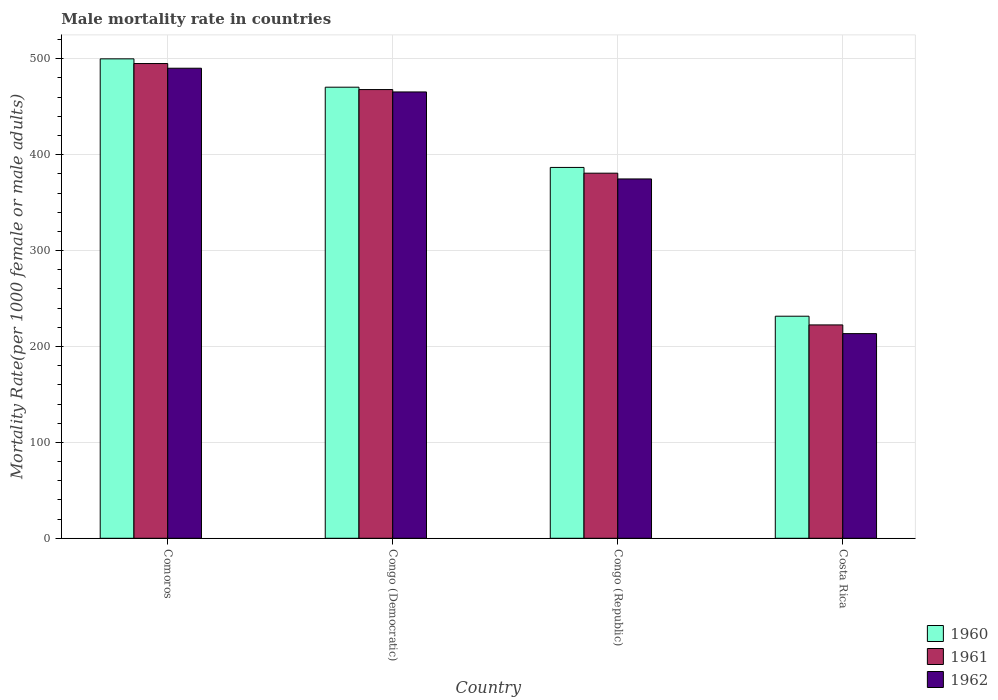Are the number of bars per tick equal to the number of legend labels?
Your answer should be compact. Yes. How many bars are there on the 4th tick from the left?
Provide a short and direct response. 3. How many bars are there on the 4th tick from the right?
Offer a terse response. 3. What is the label of the 2nd group of bars from the left?
Provide a short and direct response. Congo (Democratic). In how many cases, is the number of bars for a given country not equal to the number of legend labels?
Ensure brevity in your answer.  0. What is the male mortality rate in 1960 in Congo (Republic)?
Offer a very short reply. 386.67. Across all countries, what is the maximum male mortality rate in 1962?
Your answer should be compact. 490.1. Across all countries, what is the minimum male mortality rate in 1962?
Keep it short and to the point. 213.38. In which country was the male mortality rate in 1962 maximum?
Provide a short and direct response. Comoros. In which country was the male mortality rate in 1960 minimum?
Offer a terse response. Costa Rica. What is the total male mortality rate in 1961 in the graph?
Your answer should be very brief. 1565.96. What is the difference between the male mortality rate in 1960 in Congo (Democratic) and that in Costa Rica?
Ensure brevity in your answer.  238.8. What is the difference between the male mortality rate in 1961 in Congo (Republic) and the male mortality rate in 1960 in Costa Rica?
Provide a short and direct response. 149.13. What is the average male mortality rate in 1962 per country?
Provide a succinct answer. 385.88. What is the difference between the male mortality rate of/in 1961 and male mortality rate of/in 1962 in Comoros?
Offer a very short reply. 4.89. In how many countries, is the male mortality rate in 1960 greater than 300?
Keep it short and to the point. 3. What is the ratio of the male mortality rate in 1962 in Comoros to that in Costa Rica?
Ensure brevity in your answer.  2.3. Is the male mortality rate in 1961 in Congo (Democratic) less than that in Congo (Republic)?
Provide a succinct answer. No. Is the difference between the male mortality rate in 1961 in Comoros and Congo (Democratic) greater than the difference between the male mortality rate in 1962 in Comoros and Congo (Democratic)?
Offer a very short reply. Yes. What is the difference between the highest and the second highest male mortality rate in 1960?
Offer a very short reply. -113.21. What is the difference between the highest and the lowest male mortality rate in 1960?
Offer a terse response. 268.35. What does the 1st bar from the left in Congo (Democratic) represents?
Make the answer very short. 1960. What does the 1st bar from the right in Congo (Democratic) represents?
Your answer should be compact. 1962. How many bars are there?
Keep it short and to the point. 12. Are the values on the major ticks of Y-axis written in scientific E-notation?
Your response must be concise. No. Does the graph contain grids?
Your answer should be compact. Yes. Where does the legend appear in the graph?
Give a very brief answer. Bottom right. How many legend labels are there?
Give a very brief answer. 3. How are the legend labels stacked?
Your response must be concise. Vertical. What is the title of the graph?
Give a very brief answer. Male mortality rate in countries. Does "2002" appear as one of the legend labels in the graph?
Provide a succinct answer. No. What is the label or title of the Y-axis?
Provide a succinct answer. Mortality Rate(per 1000 female or male adults). What is the Mortality Rate(per 1000 female or male adults) in 1960 in Comoros?
Make the answer very short. 499.88. What is the Mortality Rate(per 1000 female or male adults) of 1961 in Comoros?
Make the answer very short. 494.99. What is the Mortality Rate(per 1000 female or male adults) of 1962 in Comoros?
Ensure brevity in your answer.  490.1. What is the Mortality Rate(per 1000 female or male adults) of 1960 in Congo (Democratic)?
Ensure brevity in your answer.  470.33. What is the Mortality Rate(per 1000 female or male adults) of 1961 in Congo (Democratic)?
Offer a very short reply. 467.85. What is the Mortality Rate(per 1000 female or male adults) of 1962 in Congo (Democratic)?
Your response must be concise. 465.37. What is the Mortality Rate(per 1000 female or male adults) in 1960 in Congo (Republic)?
Make the answer very short. 386.67. What is the Mortality Rate(per 1000 female or male adults) in 1961 in Congo (Republic)?
Offer a terse response. 380.66. What is the Mortality Rate(per 1000 female or male adults) in 1962 in Congo (Republic)?
Your answer should be compact. 374.66. What is the Mortality Rate(per 1000 female or male adults) of 1960 in Costa Rica?
Provide a succinct answer. 231.53. What is the Mortality Rate(per 1000 female or male adults) of 1961 in Costa Rica?
Offer a very short reply. 222.46. What is the Mortality Rate(per 1000 female or male adults) of 1962 in Costa Rica?
Offer a very short reply. 213.38. Across all countries, what is the maximum Mortality Rate(per 1000 female or male adults) in 1960?
Provide a short and direct response. 499.88. Across all countries, what is the maximum Mortality Rate(per 1000 female or male adults) of 1961?
Keep it short and to the point. 494.99. Across all countries, what is the maximum Mortality Rate(per 1000 female or male adults) in 1962?
Give a very brief answer. 490.1. Across all countries, what is the minimum Mortality Rate(per 1000 female or male adults) in 1960?
Your answer should be very brief. 231.53. Across all countries, what is the minimum Mortality Rate(per 1000 female or male adults) in 1961?
Make the answer very short. 222.46. Across all countries, what is the minimum Mortality Rate(per 1000 female or male adults) in 1962?
Your answer should be very brief. 213.38. What is the total Mortality Rate(per 1000 female or male adults) in 1960 in the graph?
Your response must be concise. 1588.41. What is the total Mortality Rate(per 1000 female or male adults) in 1961 in the graph?
Give a very brief answer. 1565.96. What is the total Mortality Rate(per 1000 female or male adults) of 1962 in the graph?
Make the answer very short. 1543.52. What is the difference between the Mortality Rate(per 1000 female or male adults) in 1960 in Comoros and that in Congo (Democratic)?
Ensure brevity in your answer.  29.55. What is the difference between the Mortality Rate(per 1000 female or male adults) in 1961 in Comoros and that in Congo (Democratic)?
Provide a succinct answer. 27.14. What is the difference between the Mortality Rate(per 1000 female or male adults) of 1962 in Comoros and that in Congo (Democratic)?
Offer a terse response. 24.73. What is the difference between the Mortality Rate(per 1000 female or male adults) in 1960 in Comoros and that in Congo (Republic)?
Your response must be concise. 113.21. What is the difference between the Mortality Rate(per 1000 female or male adults) of 1961 in Comoros and that in Congo (Republic)?
Your answer should be compact. 114.33. What is the difference between the Mortality Rate(per 1000 female or male adults) of 1962 in Comoros and that in Congo (Republic)?
Give a very brief answer. 115.44. What is the difference between the Mortality Rate(per 1000 female or male adults) in 1960 in Comoros and that in Costa Rica?
Ensure brevity in your answer.  268.35. What is the difference between the Mortality Rate(per 1000 female or male adults) of 1961 in Comoros and that in Costa Rica?
Your response must be concise. 272.53. What is the difference between the Mortality Rate(per 1000 female or male adults) of 1962 in Comoros and that in Costa Rica?
Give a very brief answer. 276.71. What is the difference between the Mortality Rate(per 1000 female or male adults) of 1960 in Congo (Democratic) and that in Congo (Republic)?
Offer a terse response. 83.66. What is the difference between the Mortality Rate(per 1000 female or male adults) in 1961 in Congo (Democratic) and that in Congo (Republic)?
Provide a succinct answer. 87.19. What is the difference between the Mortality Rate(per 1000 female or male adults) in 1962 in Congo (Democratic) and that in Congo (Republic)?
Offer a terse response. 90.71. What is the difference between the Mortality Rate(per 1000 female or male adults) in 1960 in Congo (Democratic) and that in Costa Rica?
Your answer should be compact. 238.8. What is the difference between the Mortality Rate(per 1000 female or male adults) in 1961 in Congo (Democratic) and that in Costa Rica?
Ensure brevity in your answer.  245.39. What is the difference between the Mortality Rate(per 1000 female or male adults) of 1962 in Congo (Democratic) and that in Costa Rica?
Make the answer very short. 251.99. What is the difference between the Mortality Rate(per 1000 female or male adults) of 1960 in Congo (Republic) and that in Costa Rica?
Your answer should be compact. 155.14. What is the difference between the Mortality Rate(per 1000 female or male adults) of 1961 in Congo (Republic) and that in Costa Rica?
Keep it short and to the point. 158.21. What is the difference between the Mortality Rate(per 1000 female or male adults) in 1962 in Congo (Republic) and that in Costa Rica?
Make the answer very short. 161.28. What is the difference between the Mortality Rate(per 1000 female or male adults) of 1960 in Comoros and the Mortality Rate(per 1000 female or male adults) of 1961 in Congo (Democratic)?
Ensure brevity in your answer.  32.03. What is the difference between the Mortality Rate(per 1000 female or male adults) of 1960 in Comoros and the Mortality Rate(per 1000 female or male adults) of 1962 in Congo (Democratic)?
Your answer should be very brief. 34.51. What is the difference between the Mortality Rate(per 1000 female or male adults) in 1961 in Comoros and the Mortality Rate(per 1000 female or male adults) in 1962 in Congo (Democratic)?
Ensure brevity in your answer.  29.62. What is the difference between the Mortality Rate(per 1000 female or male adults) of 1960 in Comoros and the Mortality Rate(per 1000 female or male adults) of 1961 in Congo (Republic)?
Ensure brevity in your answer.  119.22. What is the difference between the Mortality Rate(per 1000 female or male adults) of 1960 in Comoros and the Mortality Rate(per 1000 female or male adults) of 1962 in Congo (Republic)?
Keep it short and to the point. 125.22. What is the difference between the Mortality Rate(per 1000 female or male adults) in 1961 in Comoros and the Mortality Rate(per 1000 female or male adults) in 1962 in Congo (Republic)?
Your answer should be compact. 120.33. What is the difference between the Mortality Rate(per 1000 female or male adults) in 1960 in Comoros and the Mortality Rate(per 1000 female or male adults) in 1961 in Costa Rica?
Provide a succinct answer. 277.42. What is the difference between the Mortality Rate(per 1000 female or male adults) in 1960 in Comoros and the Mortality Rate(per 1000 female or male adults) in 1962 in Costa Rica?
Make the answer very short. 286.5. What is the difference between the Mortality Rate(per 1000 female or male adults) of 1961 in Comoros and the Mortality Rate(per 1000 female or male adults) of 1962 in Costa Rica?
Offer a terse response. 281.61. What is the difference between the Mortality Rate(per 1000 female or male adults) in 1960 in Congo (Democratic) and the Mortality Rate(per 1000 female or male adults) in 1961 in Congo (Republic)?
Your answer should be compact. 89.67. What is the difference between the Mortality Rate(per 1000 female or male adults) in 1960 in Congo (Democratic) and the Mortality Rate(per 1000 female or male adults) in 1962 in Congo (Republic)?
Provide a succinct answer. 95.67. What is the difference between the Mortality Rate(per 1000 female or male adults) in 1961 in Congo (Democratic) and the Mortality Rate(per 1000 female or male adults) in 1962 in Congo (Republic)?
Provide a succinct answer. 93.19. What is the difference between the Mortality Rate(per 1000 female or male adults) of 1960 in Congo (Democratic) and the Mortality Rate(per 1000 female or male adults) of 1961 in Costa Rica?
Provide a succinct answer. 247.87. What is the difference between the Mortality Rate(per 1000 female or male adults) in 1960 in Congo (Democratic) and the Mortality Rate(per 1000 female or male adults) in 1962 in Costa Rica?
Provide a succinct answer. 256.94. What is the difference between the Mortality Rate(per 1000 female or male adults) of 1961 in Congo (Democratic) and the Mortality Rate(per 1000 female or male adults) of 1962 in Costa Rica?
Give a very brief answer. 254.47. What is the difference between the Mortality Rate(per 1000 female or male adults) in 1960 in Congo (Republic) and the Mortality Rate(per 1000 female or male adults) in 1961 in Costa Rica?
Offer a terse response. 164.21. What is the difference between the Mortality Rate(per 1000 female or male adults) in 1960 in Congo (Republic) and the Mortality Rate(per 1000 female or male adults) in 1962 in Costa Rica?
Provide a short and direct response. 173.28. What is the difference between the Mortality Rate(per 1000 female or male adults) of 1961 in Congo (Republic) and the Mortality Rate(per 1000 female or male adults) of 1962 in Costa Rica?
Your answer should be very brief. 167.28. What is the average Mortality Rate(per 1000 female or male adults) in 1960 per country?
Your answer should be very brief. 397.1. What is the average Mortality Rate(per 1000 female or male adults) in 1961 per country?
Ensure brevity in your answer.  391.49. What is the average Mortality Rate(per 1000 female or male adults) of 1962 per country?
Keep it short and to the point. 385.88. What is the difference between the Mortality Rate(per 1000 female or male adults) of 1960 and Mortality Rate(per 1000 female or male adults) of 1961 in Comoros?
Provide a succinct answer. 4.89. What is the difference between the Mortality Rate(per 1000 female or male adults) of 1960 and Mortality Rate(per 1000 female or male adults) of 1962 in Comoros?
Offer a terse response. 9.78. What is the difference between the Mortality Rate(per 1000 female or male adults) of 1961 and Mortality Rate(per 1000 female or male adults) of 1962 in Comoros?
Offer a very short reply. 4.89. What is the difference between the Mortality Rate(per 1000 female or male adults) in 1960 and Mortality Rate(per 1000 female or male adults) in 1961 in Congo (Democratic)?
Ensure brevity in your answer.  2.48. What is the difference between the Mortality Rate(per 1000 female or male adults) of 1960 and Mortality Rate(per 1000 female or male adults) of 1962 in Congo (Democratic)?
Your answer should be very brief. 4.96. What is the difference between the Mortality Rate(per 1000 female or male adults) of 1961 and Mortality Rate(per 1000 female or male adults) of 1962 in Congo (Democratic)?
Keep it short and to the point. 2.48. What is the difference between the Mortality Rate(per 1000 female or male adults) of 1960 and Mortality Rate(per 1000 female or male adults) of 1961 in Congo (Republic)?
Make the answer very short. 6. What is the difference between the Mortality Rate(per 1000 female or male adults) of 1960 and Mortality Rate(per 1000 female or male adults) of 1962 in Congo (Republic)?
Offer a very short reply. 12.01. What is the difference between the Mortality Rate(per 1000 female or male adults) of 1961 and Mortality Rate(per 1000 female or male adults) of 1962 in Congo (Republic)?
Provide a succinct answer. 6. What is the difference between the Mortality Rate(per 1000 female or male adults) in 1960 and Mortality Rate(per 1000 female or male adults) in 1961 in Costa Rica?
Your answer should be compact. 9.07. What is the difference between the Mortality Rate(per 1000 female or male adults) of 1960 and Mortality Rate(per 1000 female or male adults) of 1962 in Costa Rica?
Provide a succinct answer. 18.15. What is the difference between the Mortality Rate(per 1000 female or male adults) of 1961 and Mortality Rate(per 1000 female or male adults) of 1962 in Costa Rica?
Make the answer very short. 9.07. What is the ratio of the Mortality Rate(per 1000 female or male adults) in 1960 in Comoros to that in Congo (Democratic)?
Provide a short and direct response. 1.06. What is the ratio of the Mortality Rate(per 1000 female or male adults) of 1961 in Comoros to that in Congo (Democratic)?
Give a very brief answer. 1.06. What is the ratio of the Mortality Rate(per 1000 female or male adults) in 1962 in Comoros to that in Congo (Democratic)?
Provide a succinct answer. 1.05. What is the ratio of the Mortality Rate(per 1000 female or male adults) of 1960 in Comoros to that in Congo (Republic)?
Offer a terse response. 1.29. What is the ratio of the Mortality Rate(per 1000 female or male adults) of 1961 in Comoros to that in Congo (Republic)?
Provide a short and direct response. 1.3. What is the ratio of the Mortality Rate(per 1000 female or male adults) in 1962 in Comoros to that in Congo (Republic)?
Give a very brief answer. 1.31. What is the ratio of the Mortality Rate(per 1000 female or male adults) in 1960 in Comoros to that in Costa Rica?
Give a very brief answer. 2.16. What is the ratio of the Mortality Rate(per 1000 female or male adults) in 1961 in Comoros to that in Costa Rica?
Keep it short and to the point. 2.23. What is the ratio of the Mortality Rate(per 1000 female or male adults) in 1962 in Comoros to that in Costa Rica?
Give a very brief answer. 2.3. What is the ratio of the Mortality Rate(per 1000 female or male adults) of 1960 in Congo (Democratic) to that in Congo (Republic)?
Offer a very short reply. 1.22. What is the ratio of the Mortality Rate(per 1000 female or male adults) in 1961 in Congo (Democratic) to that in Congo (Republic)?
Keep it short and to the point. 1.23. What is the ratio of the Mortality Rate(per 1000 female or male adults) in 1962 in Congo (Democratic) to that in Congo (Republic)?
Your answer should be very brief. 1.24. What is the ratio of the Mortality Rate(per 1000 female or male adults) in 1960 in Congo (Democratic) to that in Costa Rica?
Offer a very short reply. 2.03. What is the ratio of the Mortality Rate(per 1000 female or male adults) in 1961 in Congo (Democratic) to that in Costa Rica?
Your response must be concise. 2.1. What is the ratio of the Mortality Rate(per 1000 female or male adults) of 1962 in Congo (Democratic) to that in Costa Rica?
Keep it short and to the point. 2.18. What is the ratio of the Mortality Rate(per 1000 female or male adults) in 1960 in Congo (Republic) to that in Costa Rica?
Make the answer very short. 1.67. What is the ratio of the Mortality Rate(per 1000 female or male adults) in 1961 in Congo (Republic) to that in Costa Rica?
Your response must be concise. 1.71. What is the ratio of the Mortality Rate(per 1000 female or male adults) of 1962 in Congo (Republic) to that in Costa Rica?
Your answer should be very brief. 1.76. What is the difference between the highest and the second highest Mortality Rate(per 1000 female or male adults) of 1960?
Offer a terse response. 29.55. What is the difference between the highest and the second highest Mortality Rate(per 1000 female or male adults) in 1961?
Provide a succinct answer. 27.14. What is the difference between the highest and the second highest Mortality Rate(per 1000 female or male adults) of 1962?
Ensure brevity in your answer.  24.73. What is the difference between the highest and the lowest Mortality Rate(per 1000 female or male adults) in 1960?
Your answer should be compact. 268.35. What is the difference between the highest and the lowest Mortality Rate(per 1000 female or male adults) in 1961?
Your answer should be very brief. 272.53. What is the difference between the highest and the lowest Mortality Rate(per 1000 female or male adults) of 1962?
Keep it short and to the point. 276.71. 